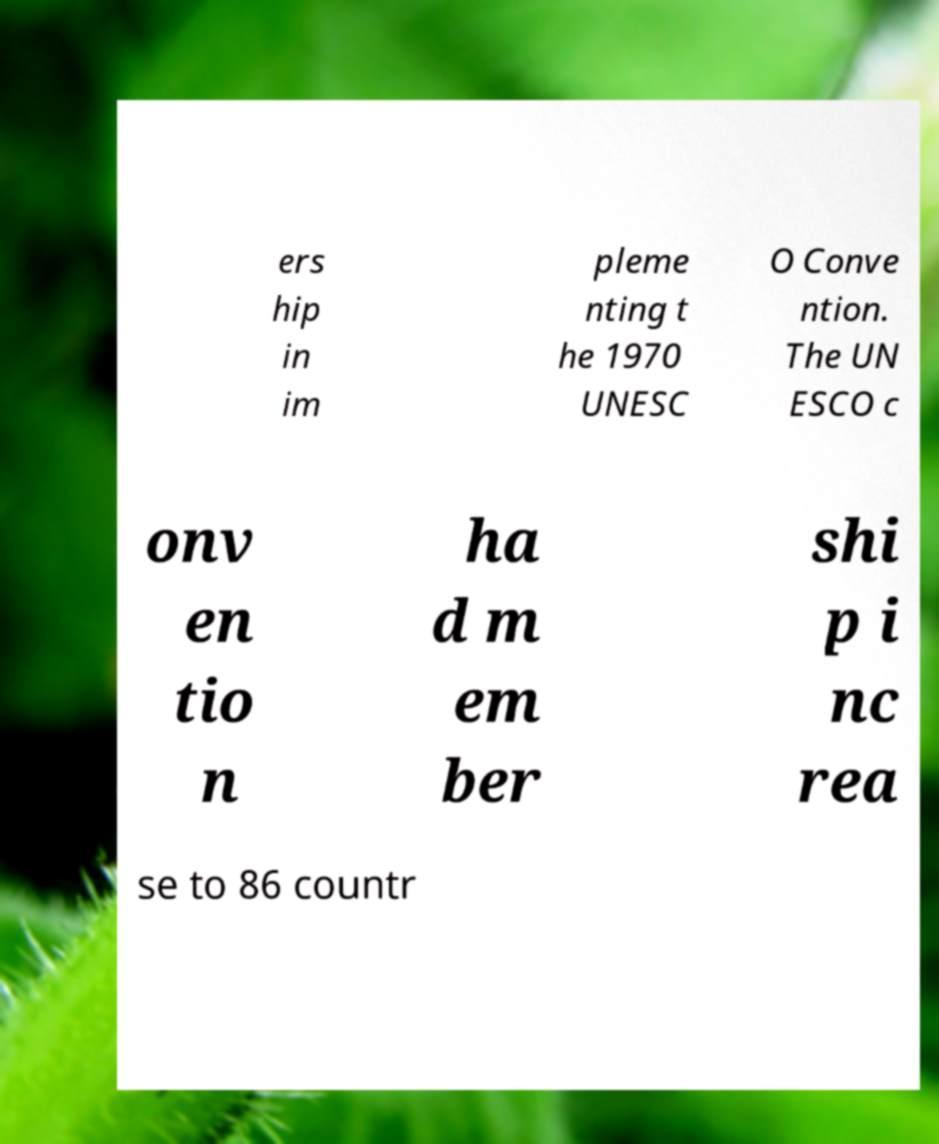Please identify and transcribe the text found in this image. ers hip in im pleme nting t he 1970 UNESC O Conve ntion. The UN ESCO c onv en tio n ha d m em ber shi p i nc rea se to 86 countr 